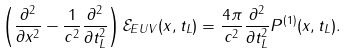Convert formula to latex. <formula><loc_0><loc_0><loc_500><loc_500>\left ( \frac { \partial ^ { 2 } } { \partial x ^ { 2 } } - \frac { 1 } { c ^ { 2 } } \frac { \partial ^ { 2 } } { \partial t _ { L } ^ { 2 } } \right ) \mathcal { E } _ { E U V } ( x , t _ { L } ) = \frac { 4 \pi } { c ^ { 2 } } \frac { \partial ^ { 2 } } { \partial t _ { L } ^ { 2 } } P ^ { ( 1 ) } ( x , t _ { L } ) .</formula> 